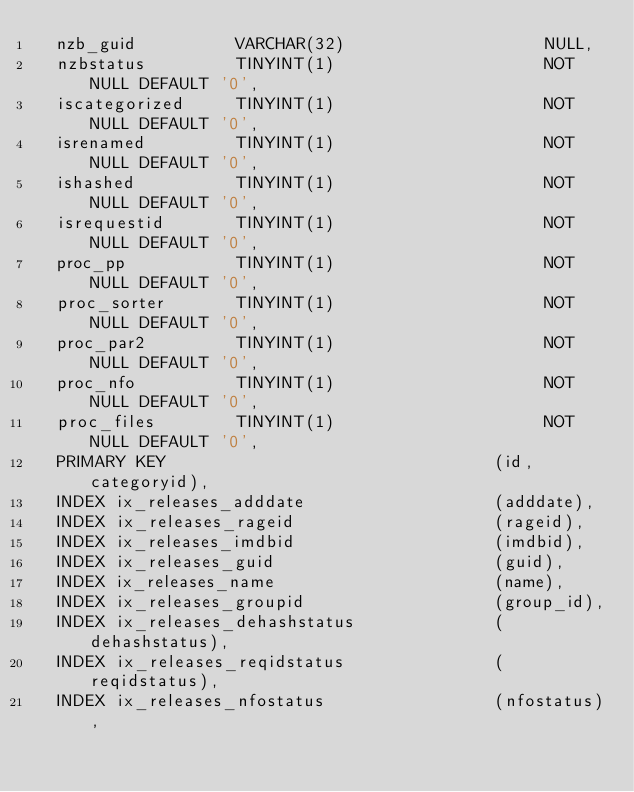<code> <loc_0><loc_0><loc_500><loc_500><_SQL_>  nzb_guid          VARCHAR(32)                    NULL,
  nzbstatus         TINYINT(1)                     NOT NULL DEFAULT '0',
  iscategorized     TINYINT(1)                     NOT NULL DEFAULT '0',
  isrenamed         TINYINT(1)                     NOT NULL DEFAULT '0',
  ishashed          TINYINT(1)                     NOT NULL DEFAULT '0',
  isrequestid       TINYINT(1)                     NOT NULL DEFAULT '0',
  proc_pp           TINYINT(1)                     NOT NULL DEFAULT '0',
  proc_sorter       TINYINT(1)                     NOT NULL DEFAULT '0',
  proc_par2         TINYINT(1)                     NOT NULL DEFAULT '0',
  proc_nfo          TINYINT(1)                     NOT NULL DEFAULT '0',
  proc_files        TINYINT(1)                     NOT NULL DEFAULT '0',
  PRIMARY KEY                                 (id, categoryid),
  INDEX ix_releases_adddate                   (adddate),
  INDEX ix_releases_rageid                    (rageid),
  INDEX ix_releases_imdbid                    (imdbid),
  INDEX ix_releases_guid                      (guid),
  INDEX ix_releases_name                      (name),
  INDEX ix_releases_groupid                   (group_id),
  INDEX ix_releases_dehashstatus              (dehashstatus),
  INDEX ix_releases_reqidstatus               (reqidstatus),
  INDEX ix_releases_nfostatus                 (nfostatus),</code> 